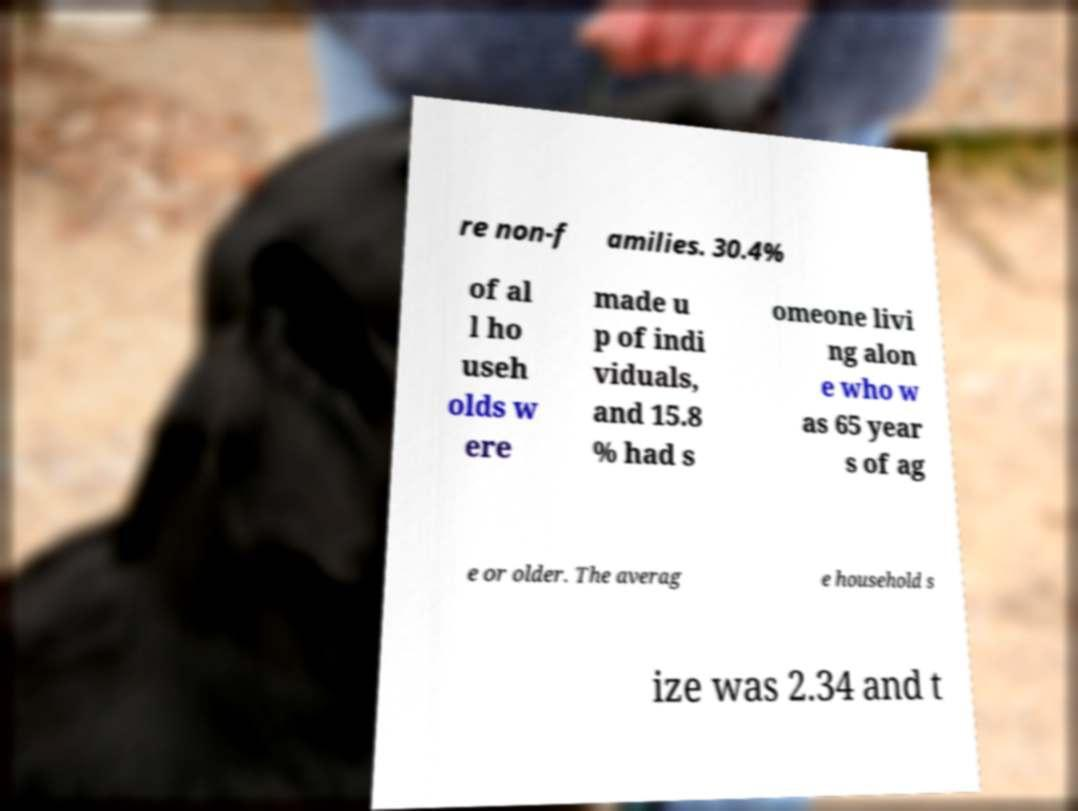There's text embedded in this image that I need extracted. Can you transcribe it verbatim? re non-f amilies. 30.4% of al l ho useh olds w ere made u p of indi viduals, and 15.8 % had s omeone livi ng alon e who w as 65 year s of ag e or older. The averag e household s ize was 2.34 and t 